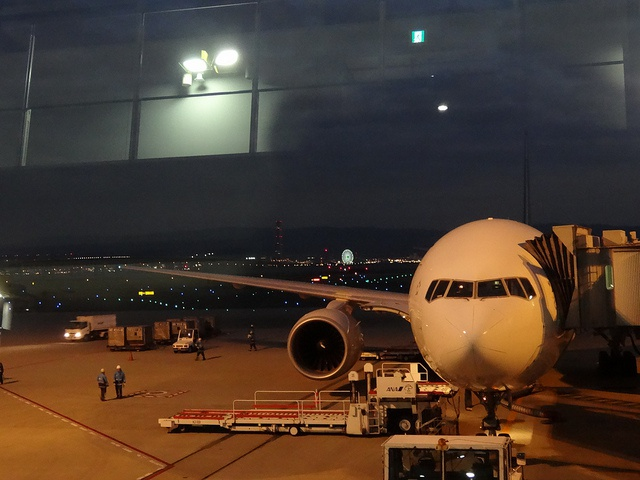Describe the objects in this image and their specific colors. I can see airplane in black, tan, maroon, and brown tones, truck in black, maroon, brown, and tan tones, truck in black, brown, and maroon tones, truck in black, maroon, and brown tones, and truck in black, maroon, brown, and salmon tones in this image. 